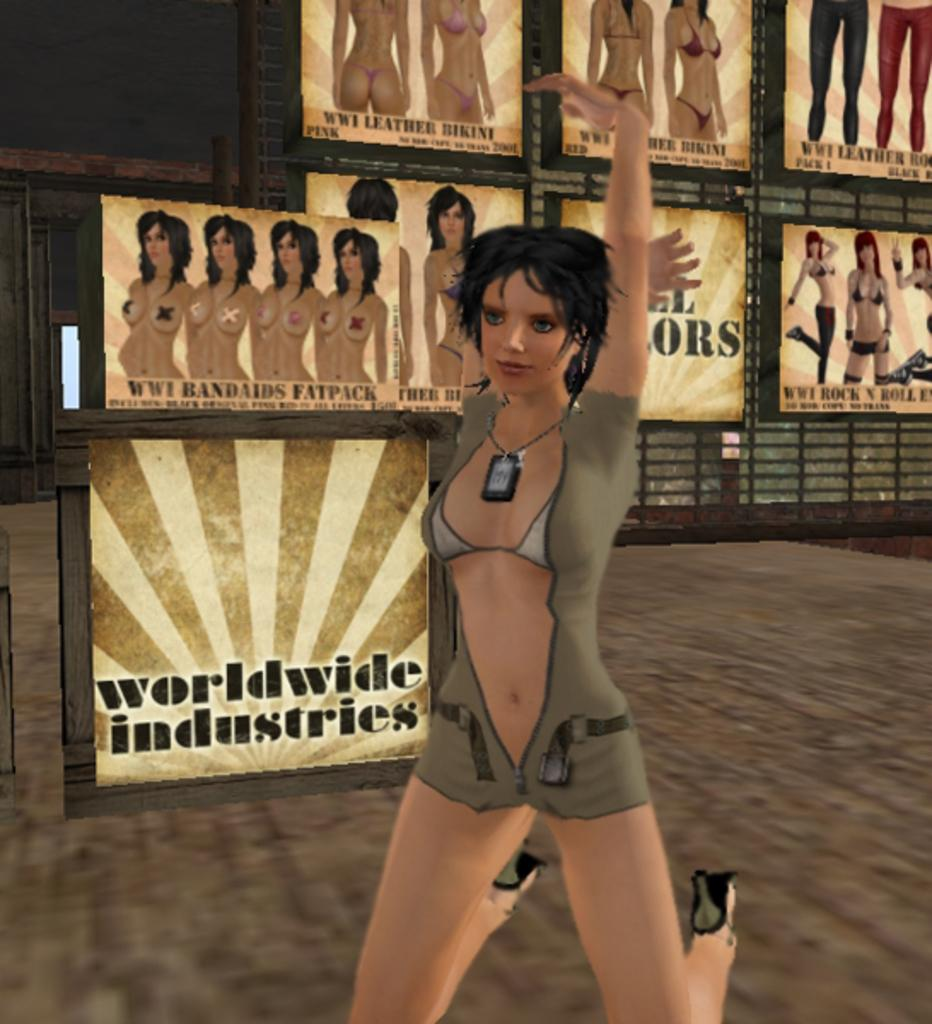What is the main subject of the image? There is a person depicted in the image. What can be seen in the background of the image? There are posters in the background of the image. What type of vegetable is being used as a wrench in the image? There is no vegetable or wrench present in the image. Where is the bedroom located in the image? There is no bedroom depicted in the image. 